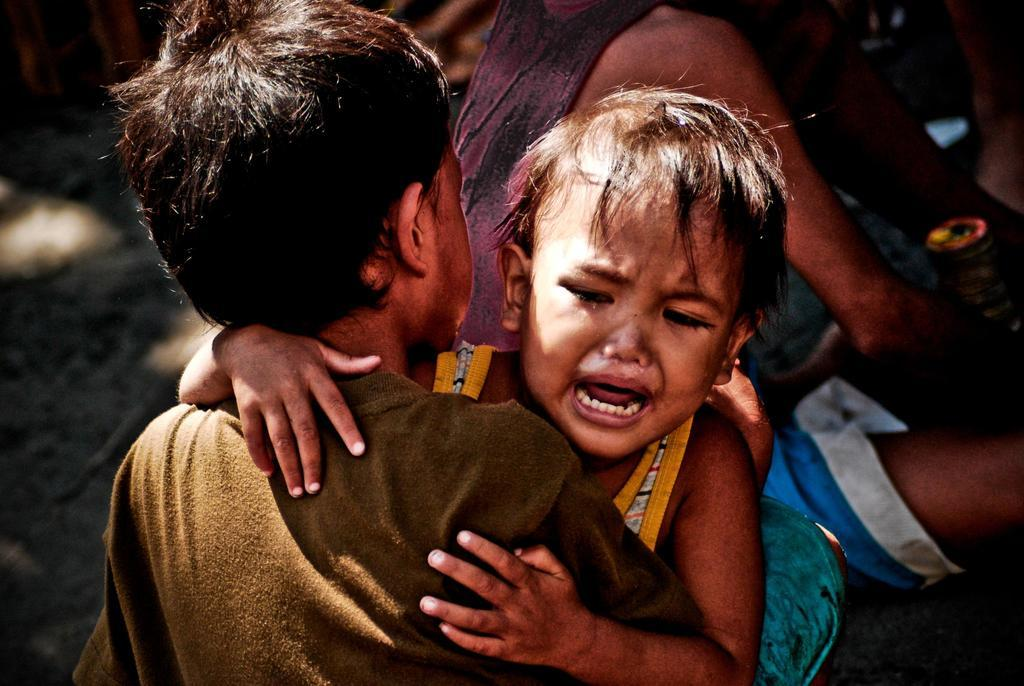What is the emotional state of the boy in the image? The boy in the image is crying. What is the crying boy doing with another boy? The crying boy is hugging another boy. Can you describe the person in the background of the image? There is a person sitting on the floor in the background of the image. What type of grass is visible in the image? There is no grass visible in the image. What color are the jeans worn by the person sitting on the floor? There is no information about the person's clothing, including jeans, in the image. 